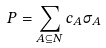<formula> <loc_0><loc_0><loc_500><loc_500>P = \sum _ { A \subseteq N } c _ { A } \sigma _ { A }</formula> 